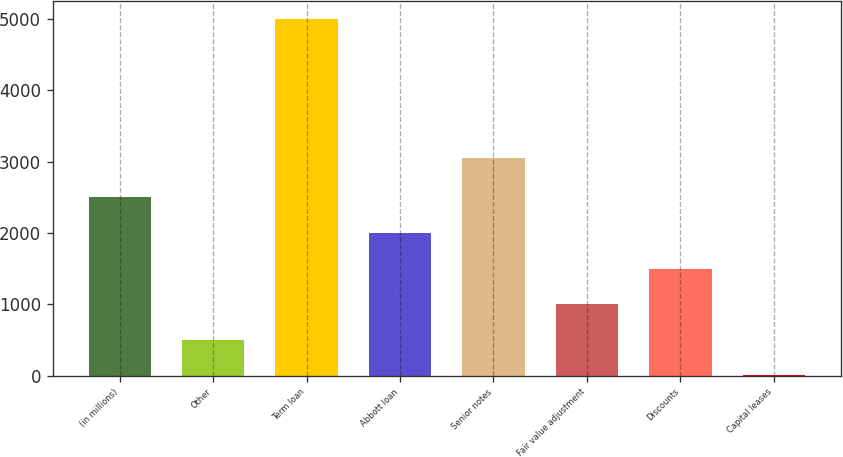Convert chart. <chart><loc_0><loc_0><loc_500><loc_500><bar_chart><fcel>(in millions)<fcel>Other<fcel>Term loan<fcel>Abbott loan<fcel>Senior notes<fcel>Fair value adjustment<fcel>Discounts<fcel>Capital leases<nl><fcel>2500.5<fcel>500.9<fcel>5000<fcel>2000.6<fcel>3050<fcel>1000.8<fcel>1500.7<fcel>1<nl></chart> 